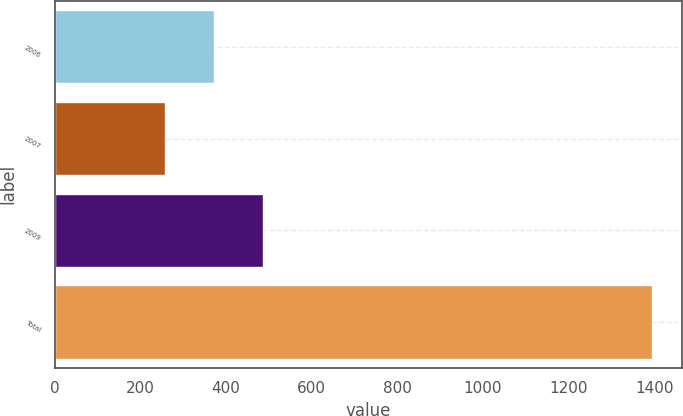Convert chart. <chart><loc_0><loc_0><loc_500><loc_500><bar_chart><fcel>2006<fcel>2007<fcel>2009<fcel>Total<nl><fcel>371.7<fcel>258<fcel>485.4<fcel>1395<nl></chart> 